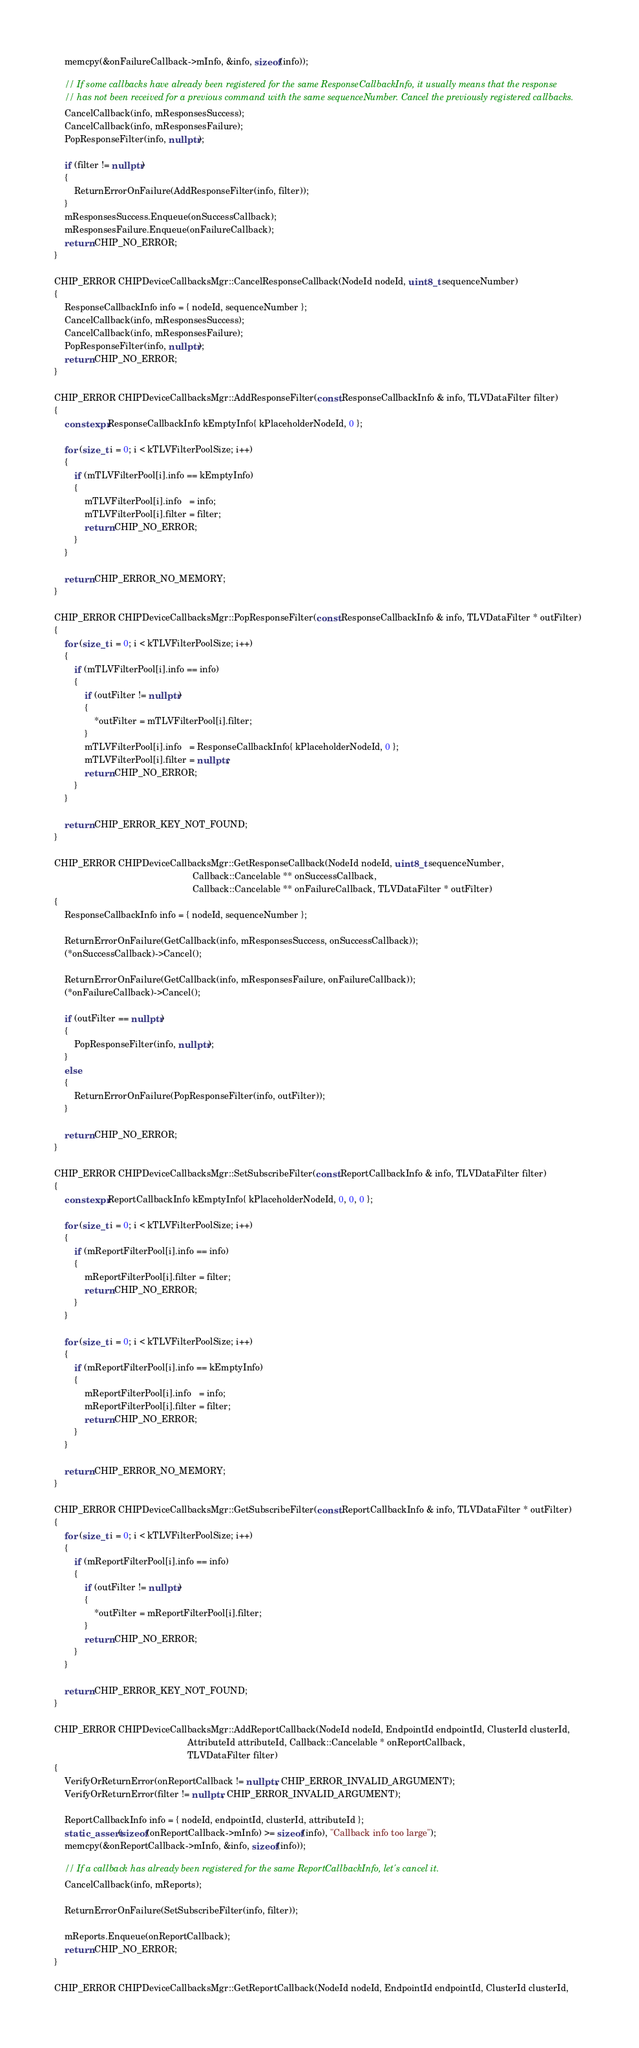<code> <loc_0><loc_0><loc_500><loc_500><_C++_>    memcpy(&onFailureCallback->mInfo, &info, sizeof(info));

    // If some callbacks have already been registered for the same ResponseCallbackInfo, it usually means that the response
    // has not been received for a previous command with the same sequenceNumber. Cancel the previously registered callbacks.
    CancelCallback(info, mResponsesSuccess);
    CancelCallback(info, mResponsesFailure);
    PopResponseFilter(info, nullptr);

    if (filter != nullptr)
    {
        ReturnErrorOnFailure(AddResponseFilter(info, filter));
    }
    mResponsesSuccess.Enqueue(onSuccessCallback);
    mResponsesFailure.Enqueue(onFailureCallback);
    return CHIP_NO_ERROR;
}

CHIP_ERROR CHIPDeviceCallbacksMgr::CancelResponseCallback(NodeId nodeId, uint8_t sequenceNumber)
{
    ResponseCallbackInfo info = { nodeId, sequenceNumber };
    CancelCallback(info, mResponsesSuccess);
    CancelCallback(info, mResponsesFailure);
    PopResponseFilter(info, nullptr);
    return CHIP_NO_ERROR;
}

CHIP_ERROR CHIPDeviceCallbacksMgr::AddResponseFilter(const ResponseCallbackInfo & info, TLVDataFilter filter)
{
    constexpr ResponseCallbackInfo kEmptyInfo{ kPlaceholderNodeId, 0 };

    for (size_t i = 0; i < kTLVFilterPoolSize; i++)
    {
        if (mTLVFilterPool[i].info == kEmptyInfo)
        {
            mTLVFilterPool[i].info   = info;
            mTLVFilterPool[i].filter = filter;
            return CHIP_NO_ERROR;
        }
    }

    return CHIP_ERROR_NO_MEMORY;
}

CHIP_ERROR CHIPDeviceCallbacksMgr::PopResponseFilter(const ResponseCallbackInfo & info, TLVDataFilter * outFilter)
{
    for (size_t i = 0; i < kTLVFilterPoolSize; i++)
    {
        if (mTLVFilterPool[i].info == info)
        {
            if (outFilter != nullptr)
            {
                *outFilter = mTLVFilterPool[i].filter;
            }
            mTLVFilterPool[i].info   = ResponseCallbackInfo{ kPlaceholderNodeId, 0 };
            mTLVFilterPool[i].filter = nullptr;
            return CHIP_NO_ERROR;
        }
    }

    return CHIP_ERROR_KEY_NOT_FOUND;
}

CHIP_ERROR CHIPDeviceCallbacksMgr::GetResponseCallback(NodeId nodeId, uint8_t sequenceNumber,
                                                       Callback::Cancelable ** onSuccessCallback,
                                                       Callback::Cancelable ** onFailureCallback, TLVDataFilter * outFilter)
{
    ResponseCallbackInfo info = { nodeId, sequenceNumber };

    ReturnErrorOnFailure(GetCallback(info, mResponsesSuccess, onSuccessCallback));
    (*onSuccessCallback)->Cancel();

    ReturnErrorOnFailure(GetCallback(info, mResponsesFailure, onFailureCallback));
    (*onFailureCallback)->Cancel();

    if (outFilter == nullptr)
    {
        PopResponseFilter(info, nullptr);
    }
    else
    {
        ReturnErrorOnFailure(PopResponseFilter(info, outFilter));
    }

    return CHIP_NO_ERROR;
}

CHIP_ERROR CHIPDeviceCallbacksMgr::SetSubscribeFilter(const ReportCallbackInfo & info, TLVDataFilter filter)
{
    constexpr ReportCallbackInfo kEmptyInfo{ kPlaceholderNodeId, 0, 0, 0 };

    for (size_t i = 0; i < kTLVFilterPoolSize; i++)
    {
        if (mReportFilterPool[i].info == info)
        {
            mReportFilterPool[i].filter = filter;
            return CHIP_NO_ERROR;
        }
    }

    for (size_t i = 0; i < kTLVFilterPoolSize; i++)
    {
        if (mReportFilterPool[i].info == kEmptyInfo)
        {
            mReportFilterPool[i].info   = info;
            mReportFilterPool[i].filter = filter;
            return CHIP_NO_ERROR;
        }
    }

    return CHIP_ERROR_NO_MEMORY;
}

CHIP_ERROR CHIPDeviceCallbacksMgr::GetSubscribeFilter(const ReportCallbackInfo & info, TLVDataFilter * outFilter)
{
    for (size_t i = 0; i < kTLVFilterPoolSize; i++)
    {
        if (mReportFilterPool[i].info == info)
        {
            if (outFilter != nullptr)
            {
                *outFilter = mReportFilterPool[i].filter;
            }
            return CHIP_NO_ERROR;
        }
    }

    return CHIP_ERROR_KEY_NOT_FOUND;
}

CHIP_ERROR CHIPDeviceCallbacksMgr::AddReportCallback(NodeId nodeId, EndpointId endpointId, ClusterId clusterId,
                                                     AttributeId attributeId, Callback::Cancelable * onReportCallback,
                                                     TLVDataFilter filter)
{
    VerifyOrReturnError(onReportCallback != nullptr, CHIP_ERROR_INVALID_ARGUMENT);
    VerifyOrReturnError(filter != nullptr, CHIP_ERROR_INVALID_ARGUMENT);

    ReportCallbackInfo info = { nodeId, endpointId, clusterId, attributeId };
    static_assert(sizeof(onReportCallback->mInfo) >= sizeof(info), "Callback info too large");
    memcpy(&onReportCallback->mInfo, &info, sizeof(info));

    // If a callback has already been registered for the same ReportCallbackInfo, let's cancel it.
    CancelCallback(info, mReports);

    ReturnErrorOnFailure(SetSubscribeFilter(info, filter));

    mReports.Enqueue(onReportCallback);
    return CHIP_NO_ERROR;
}

CHIP_ERROR CHIPDeviceCallbacksMgr::GetReportCallback(NodeId nodeId, EndpointId endpointId, ClusterId clusterId,</code> 